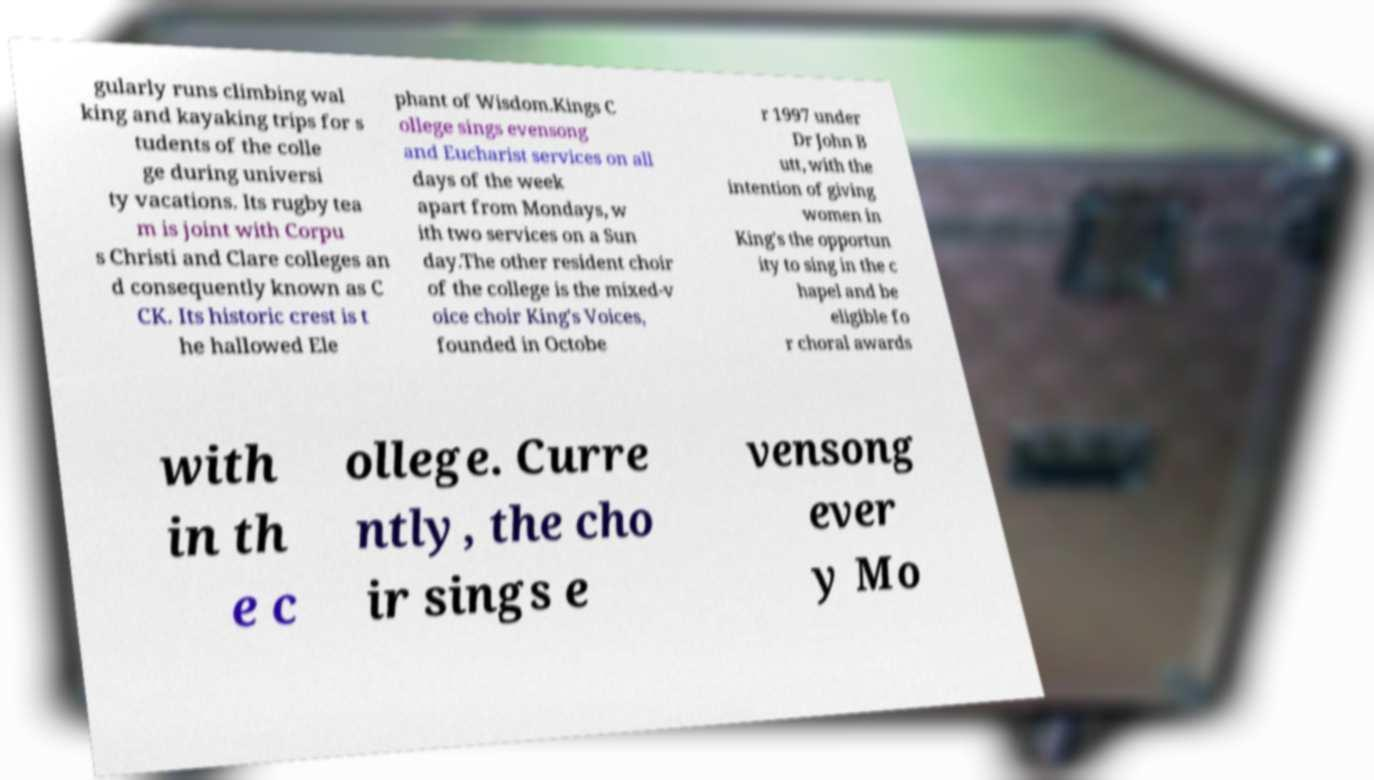What messages or text are displayed in this image? I need them in a readable, typed format. gularly runs climbing wal king and kayaking trips for s tudents of the colle ge during universi ty vacations. Its rugby tea m is joint with Corpu s Christi and Clare colleges an d consequently known as C CK. Its historic crest is t he hallowed Ele phant of Wisdom.Kings C ollege sings evensong and Eucharist services on all days of the week apart from Mondays, w ith two services on a Sun day.The other resident choir of the college is the mixed-v oice choir King's Voices, founded in Octobe r 1997 under Dr John B utt, with the intention of giving women in King's the opportun ity to sing in the c hapel and be eligible fo r choral awards with in th e c ollege. Curre ntly, the cho ir sings e vensong ever y Mo 